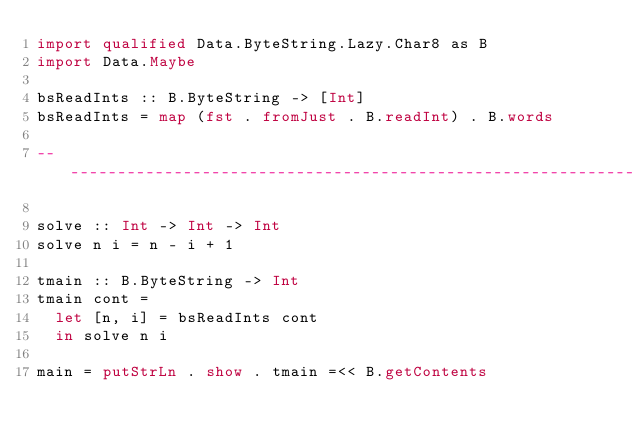<code> <loc_0><loc_0><loc_500><loc_500><_Haskell_>import qualified Data.ByteString.Lazy.Char8 as B
import Data.Maybe

bsReadInts :: B.ByteString -> [Int]
bsReadInts = map (fst . fromJust . B.readInt) . B.words

----------------------------------------------------------------------

solve :: Int -> Int -> Int
solve n i = n - i + 1

tmain :: B.ByteString -> Int
tmain cont =
  let [n, i] = bsReadInts cont
  in solve n i

main = putStrLn . show . tmain =<< B.getContents
</code> 